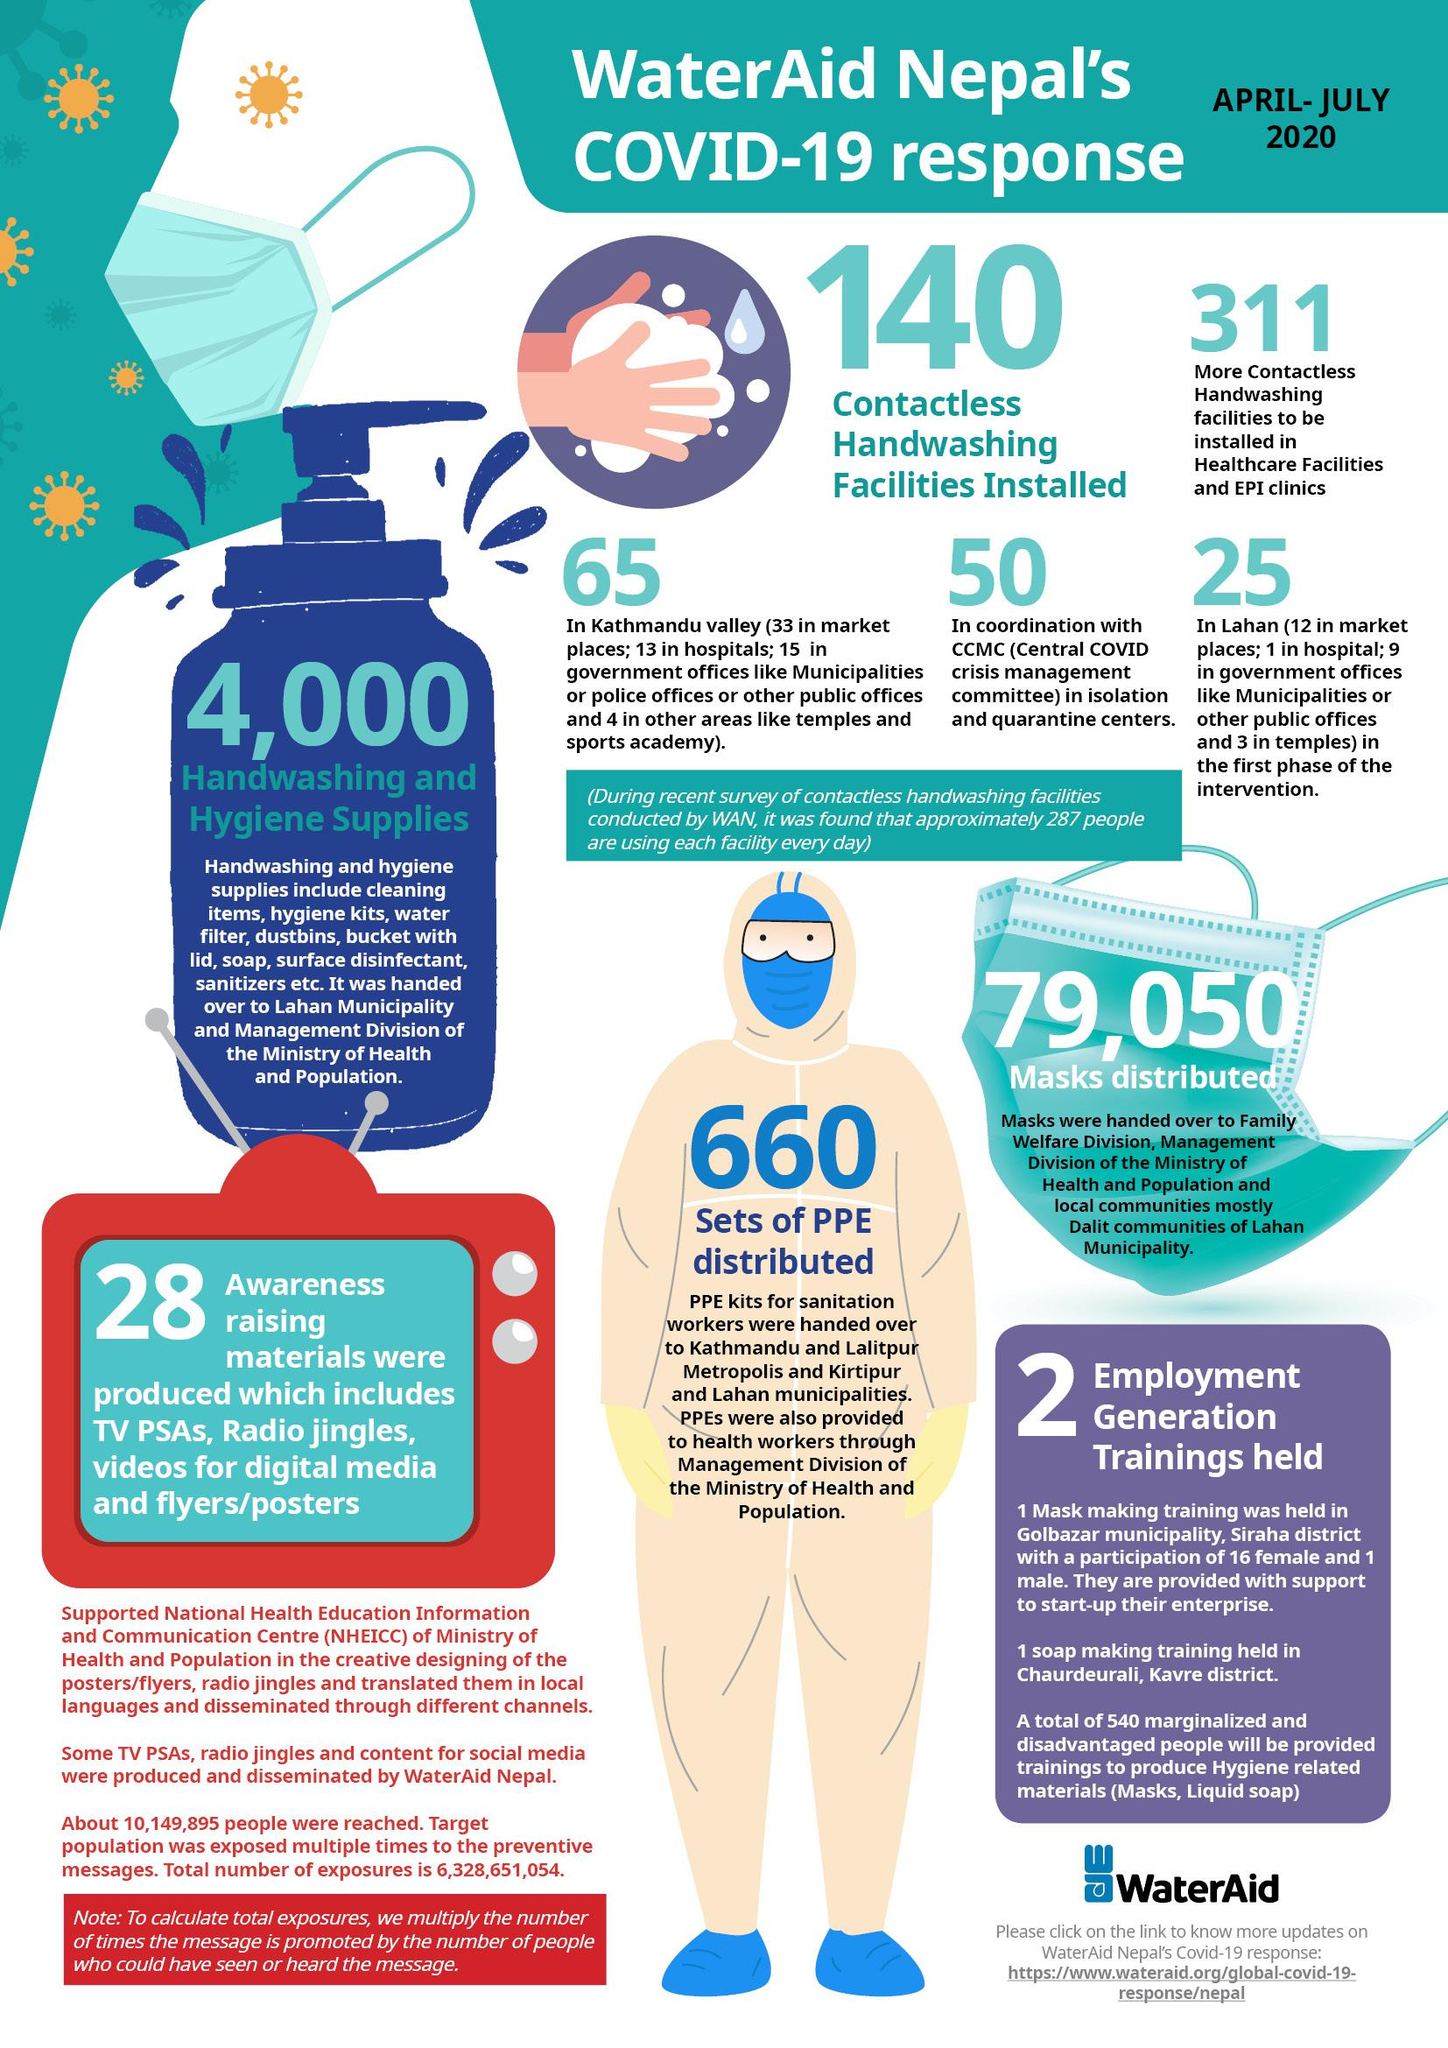Point out several critical features in this image. There are currently 140 contactless handwashing facilities installed. The number of handwashing and hygiene supplies available is 4,000. A total of 79,050 masks were distributed. A total of 660 sets of Personal Protective Equipment (PPE) were distributed. 